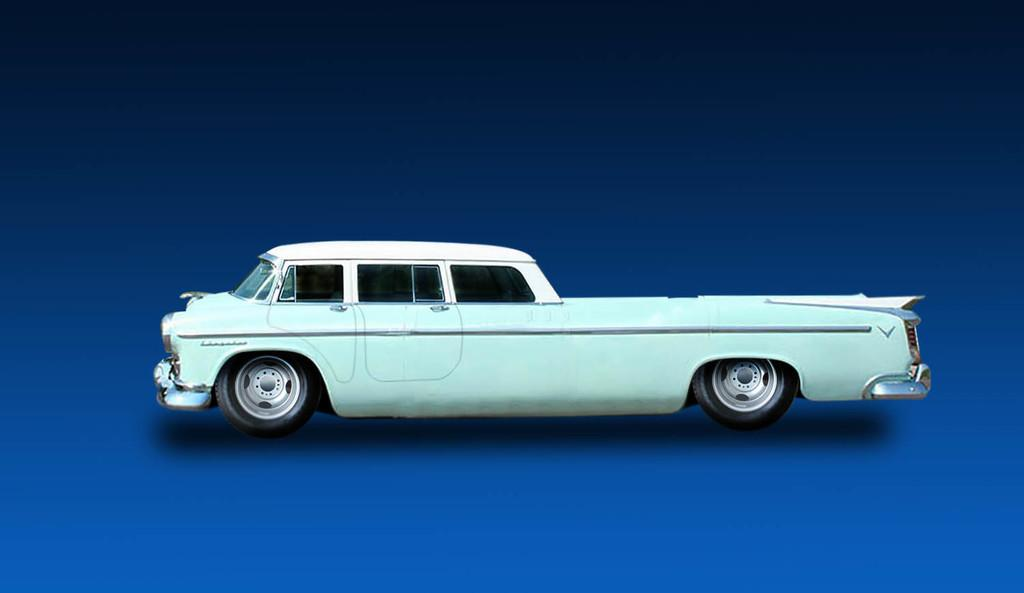What is the main subject in the center of the image? There is a car in the center of the image. What color is the background of the image? The background of the image is blue. Where is the school located in the image? There is no school present in the image; it only features a car and a blue background. What type of scale is used to weigh the parcel in the image? There is no scale or parcel present in the image; it only features a car and a blue background. 